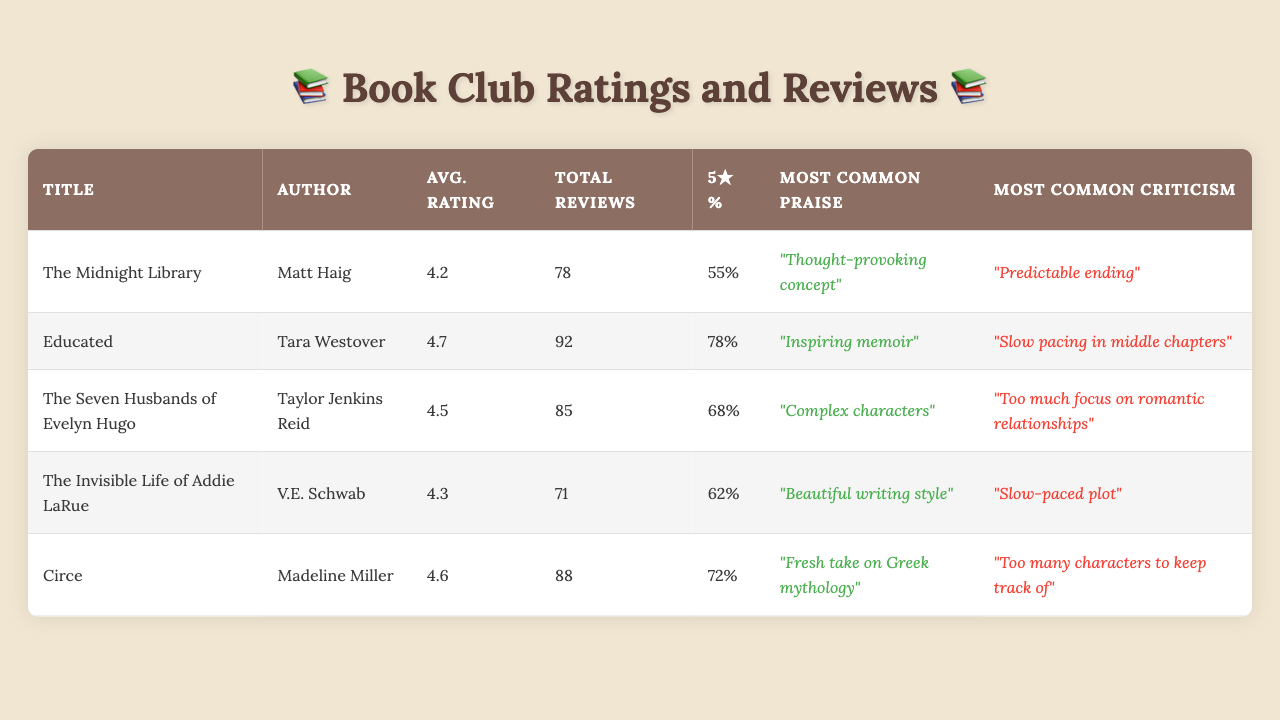What is the average rating of "Educated"? The average rating is specifically mentioned in the row for "Educated". It shows an average rating of 4.7.
Answer: 4.7 How many total reviews did "The Seven Husbands of Evelyn Hugo" receive? The total reviews are listed in the corresponding row for the book. For "The Seven Husbands of Evelyn Hugo", the total reviews are 85.
Answer: 85 Which book has the highest percentage of five-star ratings? By comparing the five-star percentages, "Educated" has the highest at 78%.
Answer: 78% What is the most common praise for "Circe"? The most common praise is provided in the row for "Circe". It states "Fresh take on Greek mythology".
Answer: "Fresh take on Greek mythology." Did "The Invisible Life of Addie LaRue" receive more reviews than "The Midnight Library"? "The Invisible Life of Addie LaRue" has 71 reviews while "The Midnight Library" has 78 reviews. Therefore, it received fewer reviews.
Answer: No What is the average rating of the five books discussed? To find the average rating, we add the ratings: (4.2 + 4.7 + 4.5 + 4.3 + 4.6) = 22.3. Then divide by the number of books, which is 5: 22.3 / 5 = 4.46.
Answer: 4.46 Which book has the most common criticism of a "slow-paced plot"? By checking the criticisms for each book, it can be seen that "The Invisible Life of Addie LaRue" received that specific criticism.
Answer: "The Invisible Life of Addie LaRue" What percentage of reviews for "The Seven Husbands of Evelyn Hugo" were five-star ratings? The row indicates that "The Seven Husbands of Evelyn Hugo" has a five-star percentage of 68%.
Answer: 68% Which book had the lowest average rating among the five discussed? By comparing average ratings, "The Midnight Library" has the lowest average at 4.2 as seen in its row.
Answer: 4.2 Which author's books were noted for having complex characters? The most common praise for "The Seven Husbands of Evelyn Hugo" specifically mentions "Complex characters", indicating Taylor Jenkins Reid is the author.
Answer: Taylor Jenkins Reid What is the total number of reviews combined for all five books? Summing the total reviews: 78 + 92 + 85 + 71 + 88 = 414.
Answer: 414 